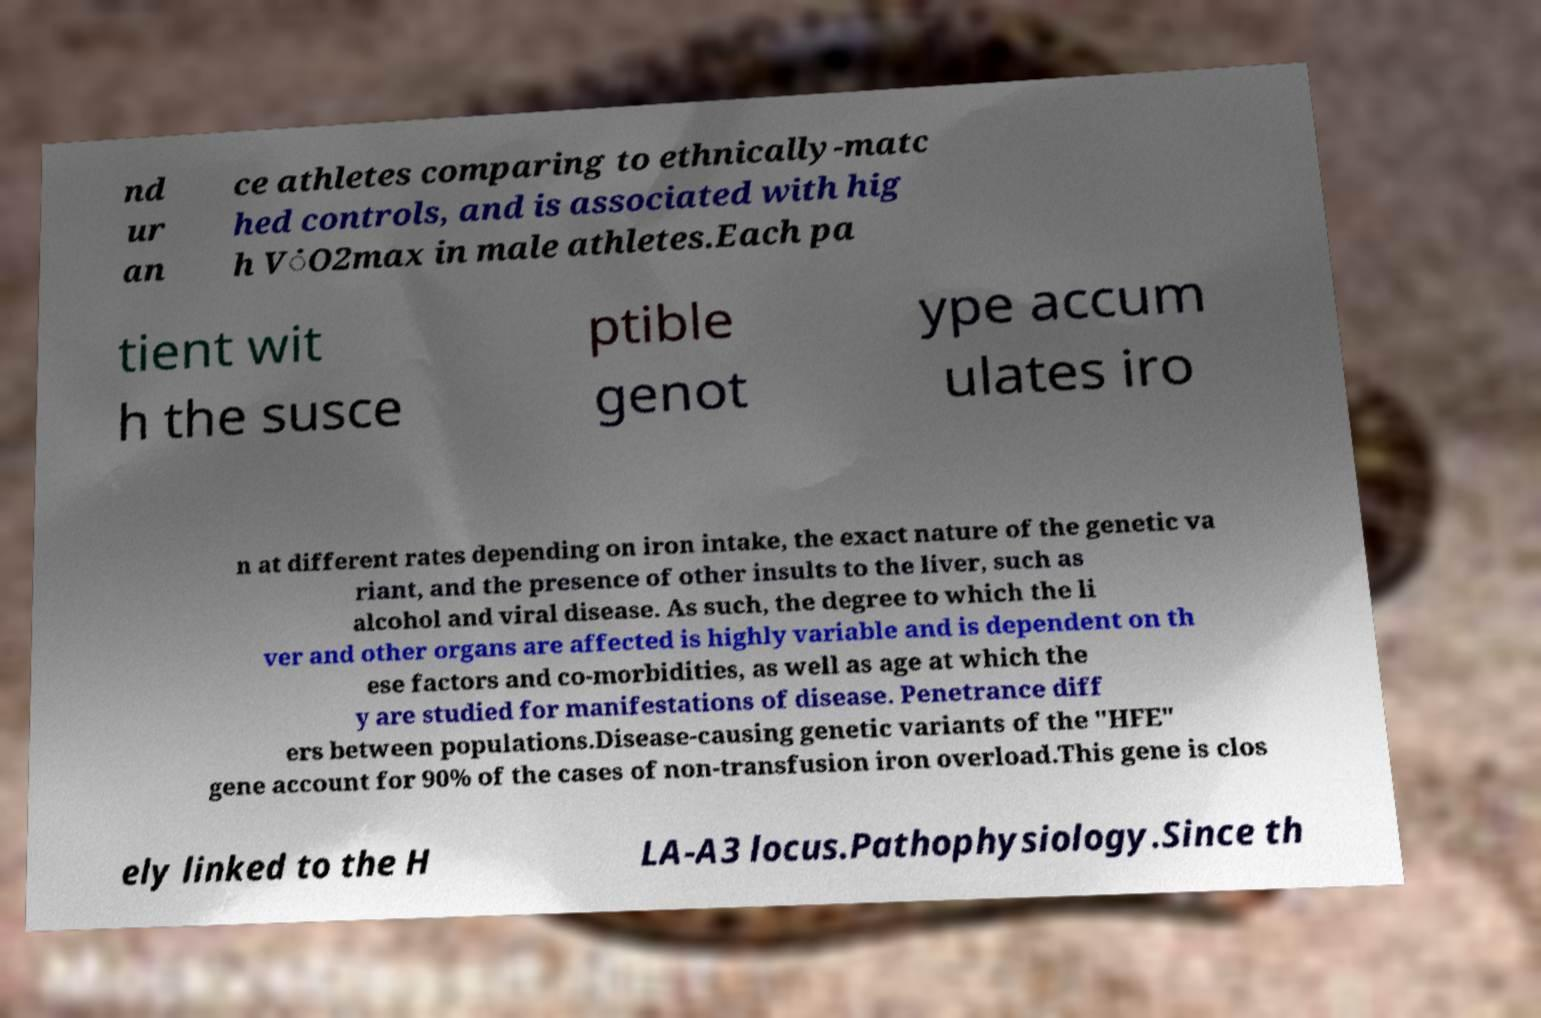Please identify and transcribe the text found in this image. nd ur an ce athletes comparing to ethnically-matc hed controls, and is associated with hig h V̇O2max in male athletes.Each pa tient wit h the susce ptible genot ype accum ulates iro n at different rates depending on iron intake, the exact nature of the genetic va riant, and the presence of other insults to the liver, such as alcohol and viral disease. As such, the degree to which the li ver and other organs are affected is highly variable and is dependent on th ese factors and co-morbidities, as well as age at which the y are studied for manifestations of disease. Penetrance diff ers between populations.Disease-causing genetic variants of the "HFE" gene account for 90% of the cases of non-transfusion iron overload.This gene is clos ely linked to the H LA-A3 locus.Pathophysiology.Since th 